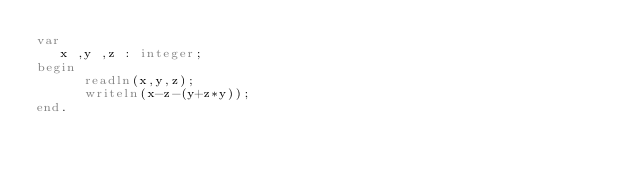<code> <loc_0><loc_0><loc_500><loc_500><_Pascal_>var
   x ,y ,z : integer;
begin
      readln(x,y,z);
      writeln(x-z-(y+z*y));
end.</code> 